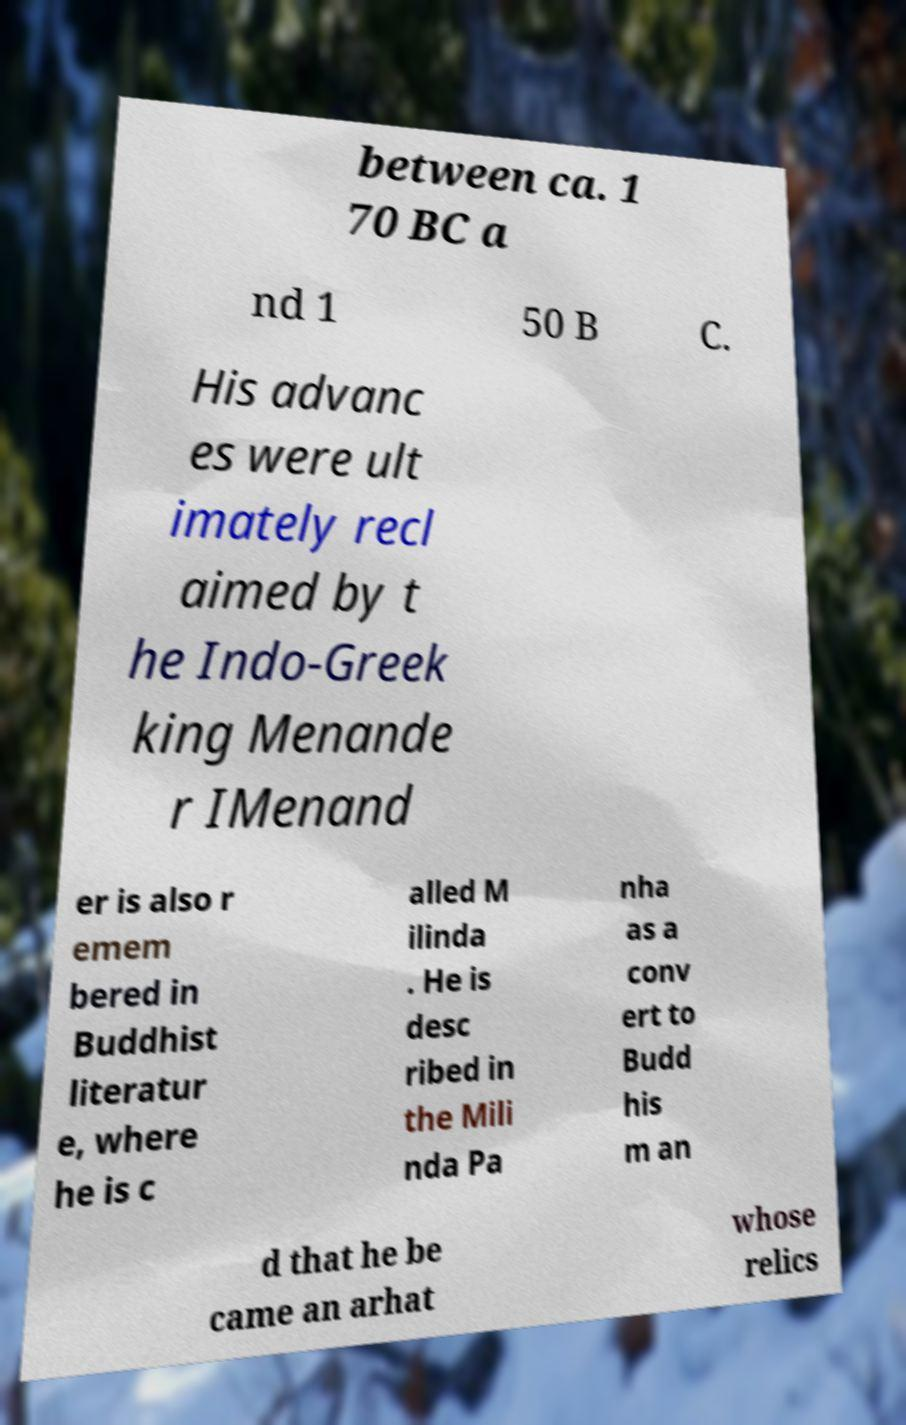Can you read and provide the text displayed in the image?This photo seems to have some interesting text. Can you extract and type it out for me? between ca. 1 70 BC a nd 1 50 B C. His advanc es were ult imately recl aimed by t he Indo-Greek king Menande r IMenand er is also r emem bered in Buddhist literatur e, where he is c alled M ilinda . He is desc ribed in the Mili nda Pa nha as a conv ert to Budd his m an d that he be came an arhat whose relics 